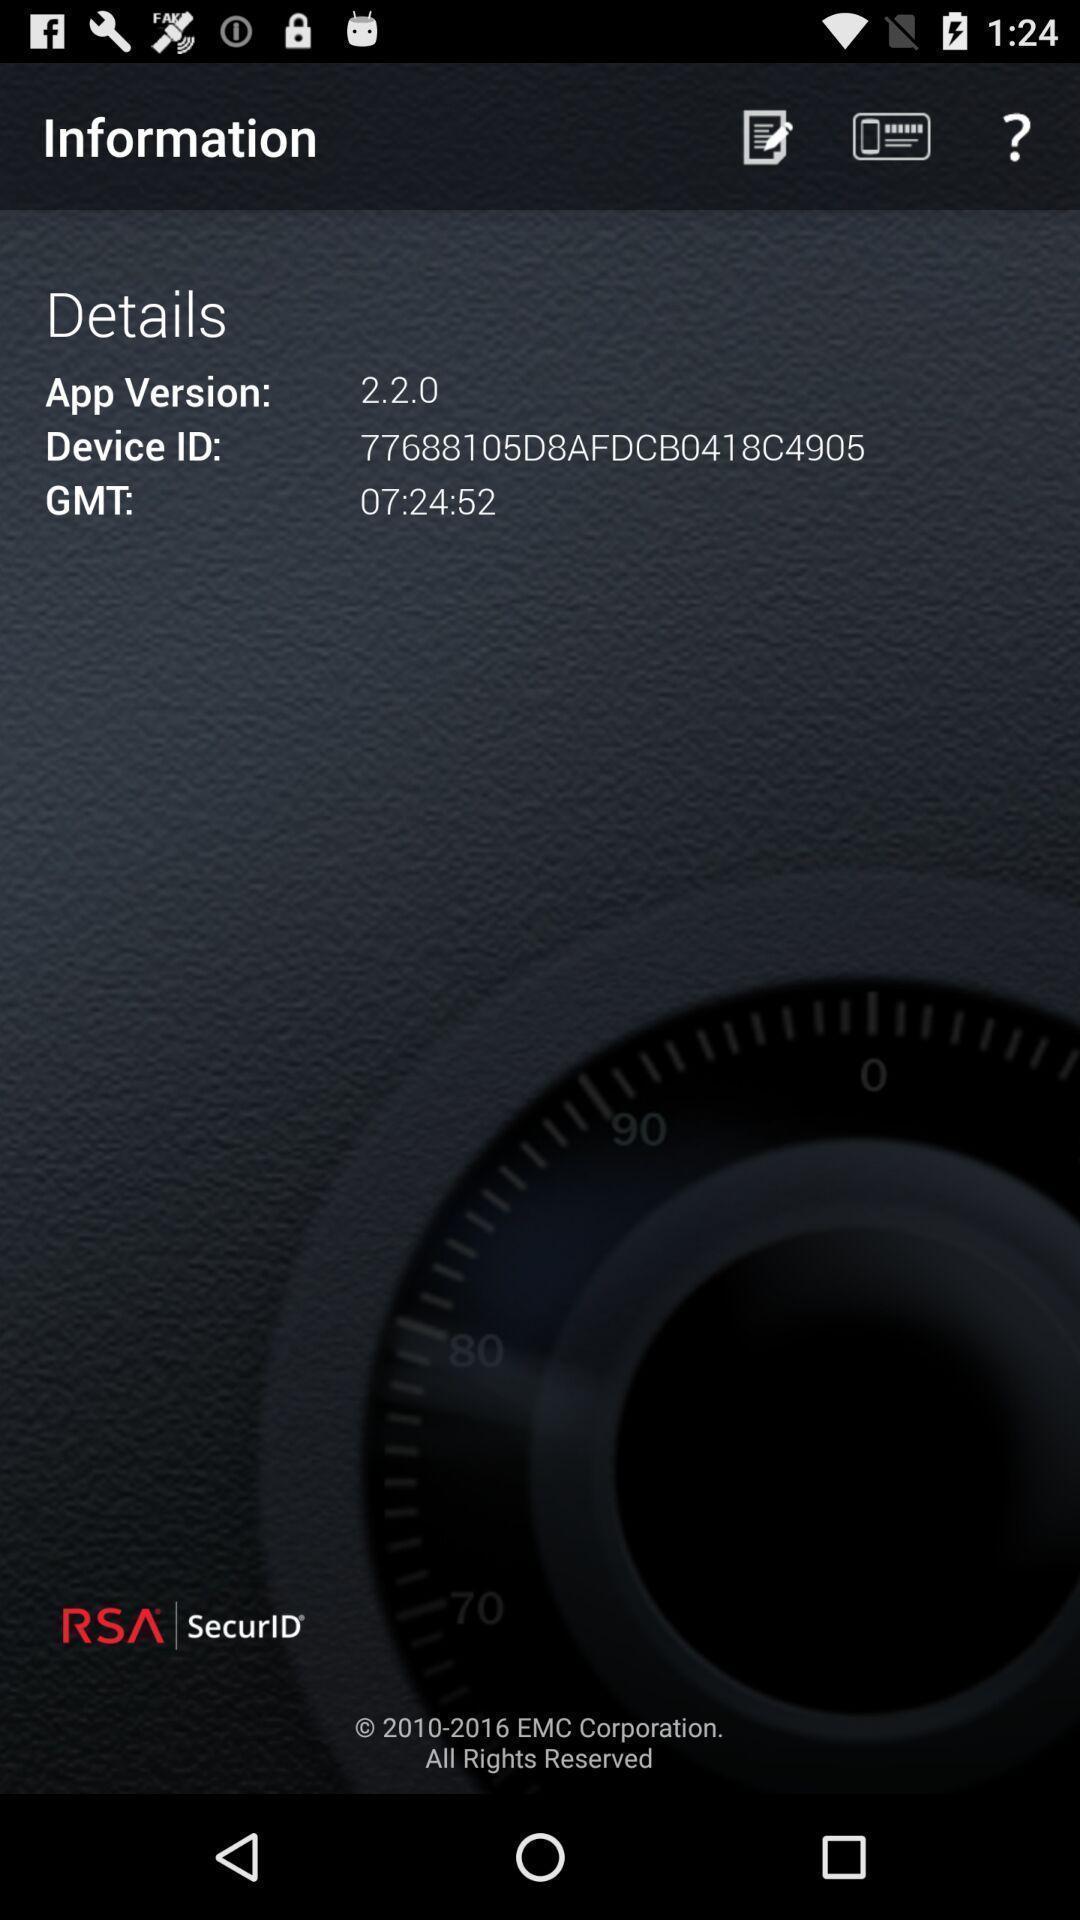Tell me what you see in this picture. Screen displaying detailed information about the application. 